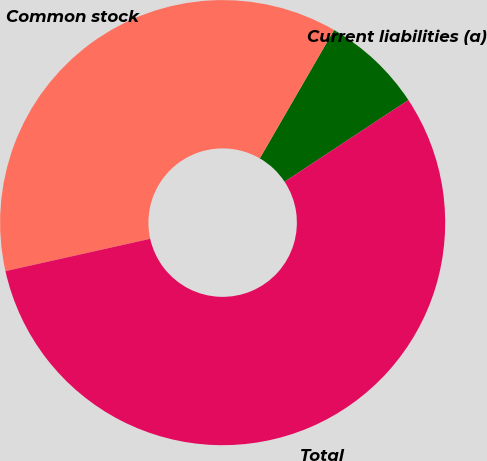Convert chart. <chart><loc_0><loc_0><loc_500><loc_500><pie_chart><fcel>Current liabilities (a)<fcel>Common stock<fcel>Total<nl><fcel>7.37%<fcel>36.84%<fcel>55.79%<nl></chart> 